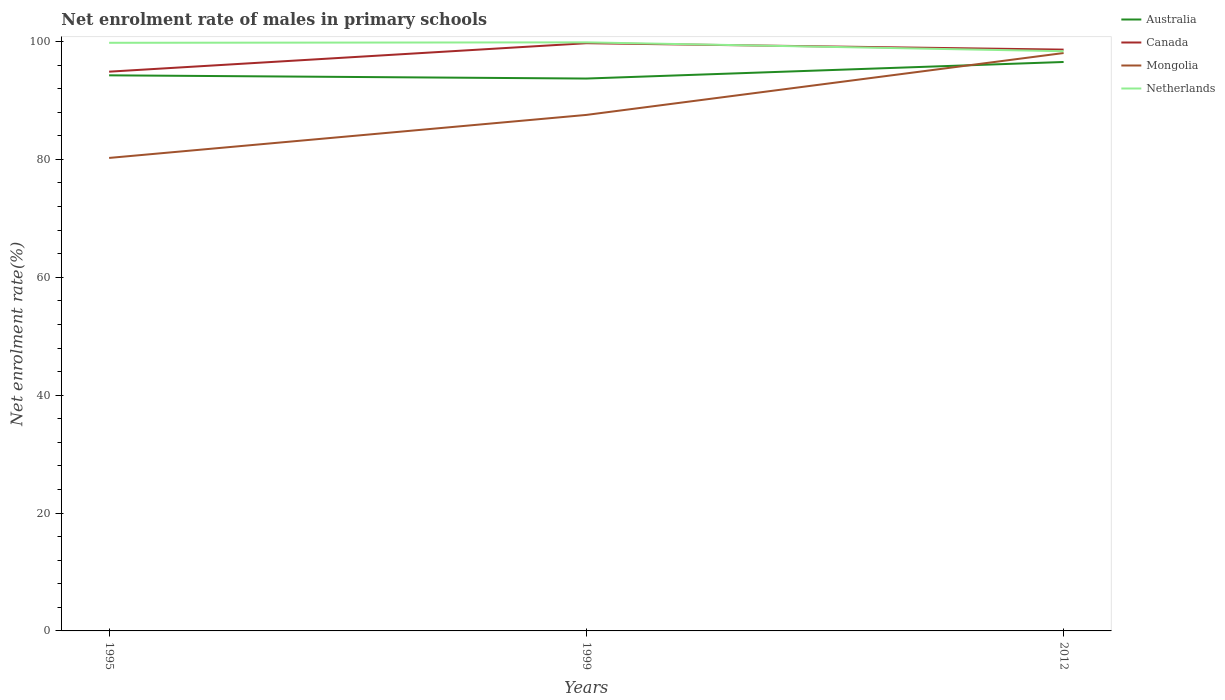Across all years, what is the maximum net enrolment rate of males in primary schools in Australia?
Offer a very short reply. 93.72. What is the total net enrolment rate of males in primary schools in Canada in the graph?
Offer a very short reply. -3.74. What is the difference between the highest and the second highest net enrolment rate of males in primary schools in Netherlands?
Your answer should be very brief. 1.51. How many years are there in the graph?
Offer a terse response. 3. Are the values on the major ticks of Y-axis written in scientific E-notation?
Your response must be concise. No. How many legend labels are there?
Give a very brief answer. 4. What is the title of the graph?
Your answer should be compact. Net enrolment rate of males in primary schools. Does "Faeroe Islands" appear as one of the legend labels in the graph?
Provide a short and direct response. No. What is the label or title of the Y-axis?
Provide a succinct answer. Net enrolment rate(%). What is the Net enrolment rate(%) in Australia in 1995?
Provide a succinct answer. 94.27. What is the Net enrolment rate(%) of Canada in 1995?
Provide a succinct answer. 94.89. What is the Net enrolment rate(%) in Mongolia in 1995?
Your response must be concise. 80.25. What is the Net enrolment rate(%) of Netherlands in 1995?
Your answer should be very brief. 99.79. What is the Net enrolment rate(%) of Australia in 1999?
Your answer should be compact. 93.72. What is the Net enrolment rate(%) of Canada in 1999?
Make the answer very short. 99.72. What is the Net enrolment rate(%) of Mongolia in 1999?
Offer a terse response. 87.55. What is the Net enrolment rate(%) in Netherlands in 1999?
Provide a succinct answer. 99.86. What is the Net enrolment rate(%) of Australia in 2012?
Provide a short and direct response. 96.53. What is the Net enrolment rate(%) of Canada in 2012?
Ensure brevity in your answer.  98.63. What is the Net enrolment rate(%) in Mongolia in 2012?
Give a very brief answer. 98.05. What is the Net enrolment rate(%) of Netherlands in 2012?
Offer a very short reply. 98.36. Across all years, what is the maximum Net enrolment rate(%) of Australia?
Keep it short and to the point. 96.53. Across all years, what is the maximum Net enrolment rate(%) in Canada?
Your response must be concise. 99.72. Across all years, what is the maximum Net enrolment rate(%) in Mongolia?
Your response must be concise. 98.05. Across all years, what is the maximum Net enrolment rate(%) in Netherlands?
Give a very brief answer. 99.86. Across all years, what is the minimum Net enrolment rate(%) of Australia?
Provide a short and direct response. 93.72. Across all years, what is the minimum Net enrolment rate(%) in Canada?
Provide a succinct answer. 94.89. Across all years, what is the minimum Net enrolment rate(%) of Mongolia?
Keep it short and to the point. 80.25. Across all years, what is the minimum Net enrolment rate(%) of Netherlands?
Provide a short and direct response. 98.36. What is the total Net enrolment rate(%) of Australia in the graph?
Make the answer very short. 284.52. What is the total Net enrolment rate(%) in Canada in the graph?
Provide a succinct answer. 293.23. What is the total Net enrolment rate(%) in Mongolia in the graph?
Offer a very short reply. 265.85. What is the total Net enrolment rate(%) of Netherlands in the graph?
Ensure brevity in your answer.  298. What is the difference between the Net enrolment rate(%) in Australia in 1995 and that in 1999?
Offer a terse response. 0.55. What is the difference between the Net enrolment rate(%) in Canada in 1995 and that in 1999?
Provide a succinct answer. -4.83. What is the difference between the Net enrolment rate(%) in Mongolia in 1995 and that in 1999?
Keep it short and to the point. -7.3. What is the difference between the Net enrolment rate(%) in Netherlands in 1995 and that in 1999?
Your response must be concise. -0.08. What is the difference between the Net enrolment rate(%) in Australia in 1995 and that in 2012?
Give a very brief answer. -2.26. What is the difference between the Net enrolment rate(%) in Canada in 1995 and that in 2012?
Keep it short and to the point. -3.74. What is the difference between the Net enrolment rate(%) in Mongolia in 1995 and that in 2012?
Ensure brevity in your answer.  -17.8. What is the difference between the Net enrolment rate(%) in Netherlands in 1995 and that in 2012?
Ensure brevity in your answer.  1.43. What is the difference between the Net enrolment rate(%) of Australia in 1999 and that in 2012?
Your answer should be compact. -2.81. What is the difference between the Net enrolment rate(%) of Canada in 1999 and that in 2012?
Keep it short and to the point. 1.09. What is the difference between the Net enrolment rate(%) of Mongolia in 1999 and that in 2012?
Offer a terse response. -10.5. What is the difference between the Net enrolment rate(%) in Netherlands in 1999 and that in 2012?
Offer a terse response. 1.51. What is the difference between the Net enrolment rate(%) in Australia in 1995 and the Net enrolment rate(%) in Canada in 1999?
Ensure brevity in your answer.  -5.45. What is the difference between the Net enrolment rate(%) in Australia in 1995 and the Net enrolment rate(%) in Mongolia in 1999?
Your answer should be very brief. 6.72. What is the difference between the Net enrolment rate(%) in Australia in 1995 and the Net enrolment rate(%) in Netherlands in 1999?
Ensure brevity in your answer.  -5.59. What is the difference between the Net enrolment rate(%) in Canada in 1995 and the Net enrolment rate(%) in Mongolia in 1999?
Your response must be concise. 7.34. What is the difference between the Net enrolment rate(%) in Canada in 1995 and the Net enrolment rate(%) in Netherlands in 1999?
Keep it short and to the point. -4.97. What is the difference between the Net enrolment rate(%) in Mongolia in 1995 and the Net enrolment rate(%) in Netherlands in 1999?
Offer a terse response. -19.61. What is the difference between the Net enrolment rate(%) of Australia in 1995 and the Net enrolment rate(%) of Canada in 2012?
Offer a terse response. -4.36. What is the difference between the Net enrolment rate(%) of Australia in 1995 and the Net enrolment rate(%) of Mongolia in 2012?
Offer a very short reply. -3.78. What is the difference between the Net enrolment rate(%) of Australia in 1995 and the Net enrolment rate(%) of Netherlands in 2012?
Your answer should be very brief. -4.09. What is the difference between the Net enrolment rate(%) of Canada in 1995 and the Net enrolment rate(%) of Mongolia in 2012?
Provide a short and direct response. -3.16. What is the difference between the Net enrolment rate(%) of Canada in 1995 and the Net enrolment rate(%) of Netherlands in 2012?
Offer a terse response. -3.47. What is the difference between the Net enrolment rate(%) of Mongolia in 1995 and the Net enrolment rate(%) of Netherlands in 2012?
Offer a very short reply. -18.1. What is the difference between the Net enrolment rate(%) in Australia in 1999 and the Net enrolment rate(%) in Canada in 2012?
Provide a short and direct response. -4.91. What is the difference between the Net enrolment rate(%) of Australia in 1999 and the Net enrolment rate(%) of Mongolia in 2012?
Offer a terse response. -4.33. What is the difference between the Net enrolment rate(%) of Australia in 1999 and the Net enrolment rate(%) of Netherlands in 2012?
Give a very brief answer. -4.64. What is the difference between the Net enrolment rate(%) of Canada in 1999 and the Net enrolment rate(%) of Mongolia in 2012?
Your answer should be very brief. 1.67. What is the difference between the Net enrolment rate(%) of Canada in 1999 and the Net enrolment rate(%) of Netherlands in 2012?
Your response must be concise. 1.36. What is the difference between the Net enrolment rate(%) of Mongolia in 1999 and the Net enrolment rate(%) of Netherlands in 2012?
Your response must be concise. -10.81. What is the average Net enrolment rate(%) of Australia per year?
Keep it short and to the point. 94.84. What is the average Net enrolment rate(%) of Canada per year?
Your answer should be very brief. 97.74. What is the average Net enrolment rate(%) in Mongolia per year?
Your answer should be very brief. 88.62. What is the average Net enrolment rate(%) in Netherlands per year?
Your response must be concise. 99.33. In the year 1995, what is the difference between the Net enrolment rate(%) in Australia and Net enrolment rate(%) in Canada?
Offer a terse response. -0.62. In the year 1995, what is the difference between the Net enrolment rate(%) of Australia and Net enrolment rate(%) of Mongolia?
Provide a succinct answer. 14.02. In the year 1995, what is the difference between the Net enrolment rate(%) of Australia and Net enrolment rate(%) of Netherlands?
Give a very brief answer. -5.52. In the year 1995, what is the difference between the Net enrolment rate(%) in Canada and Net enrolment rate(%) in Mongolia?
Provide a short and direct response. 14.63. In the year 1995, what is the difference between the Net enrolment rate(%) of Canada and Net enrolment rate(%) of Netherlands?
Keep it short and to the point. -4.9. In the year 1995, what is the difference between the Net enrolment rate(%) in Mongolia and Net enrolment rate(%) in Netherlands?
Make the answer very short. -19.53. In the year 1999, what is the difference between the Net enrolment rate(%) of Australia and Net enrolment rate(%) of Canada?
Offer a very short reply. -6. In the year 1999, what is the difference between the Net enrolment rate(%) in Australia and Net enrolment rate(%) in Mongolia?
Your answer should be very brief. 6.17. In the year 1999, what is the difference between the Net enrolment rate(%) in Australia and Net enrolment rate(%) in Netherlands?
Offer a terse response. -6.14. In the year 1999, what is the difference between the Net enrolment rate(%) in Canada and Net enrolment rate(%) in Mongolia?
Provide a short and direct response. 12.17. In the year 1999, what is the difference between the Net enrolment rate(%) of Canada and Net enrolment rate(%) of Netherlands?
Your answer should be compact. -0.14. In the year 1999, what is the difference between the Net enrolment rate(%) in Mongolia and Net enrolment rate(%) in Netherlands?
Offer a very short reply. -12.31. In the year 2012, what is the difference between the Net enrolment rate(%) of Australia and Net enrolment rate(%) of Canada?
Keep it short and to the point. -2.1. In the year 2012, what is the difference between the Net enrolment rate(%) of Australia and Net enrolment rate(%) of Mongolia?
Give a very brief answer. -1.52. In the year 2012, what is the difference between the Net enrolment rate(%) of Australia and Net enrolment rate(%) of Netherlands?
Provide a succinct answer. -1.82. In the year 2012, what is the difference between the Net enrolment rate(%) in Canada and Net enrolment rate(%) in Mongolia?
Your answer should be very brief. 0.58. In the year 2012, what is the difference between the Net enrolment rate(%) in Canada and Net enrolment rate(%) in Netherlands?
Make the answer very short. 0.27. In the year 2012, what is the difference between the Net enrolment rate(%) of Mongolia and Net enrolment rate(%) of Netherlands?
Your answer should be compact. -0.3. What is the ratio of the Net enrolment rate(%) in Australia in 1995 to that in 1999?
Make the answer very short. 1.01. What is the ratio of the Net enrolment rate(%) of Canada in 1995 to that in 1999?
Your answer should be very brief. 0.95. What is the ratio of the Net enrolment rate(%) in Mongolia in 1995 to that in 1999?
Make the answer very short. 0.92. What is the ratio of the Net enrolment rate(%) in Netherlands in 1995 to that in 1999?
Offer a terse response. 1. What is the ratio of the Net enrolment rate(%) in Australia in 1995 to that in 2012?
Give a very brief answer. 0.98. What is the ratio of the Net enrolment rate(%) in Canada in 1995 to that in 2012?
Offer a very short reply. 0.96. What is the ratio of the Net enrolment rate(%) of Mongolia in 1995 to that in 2012?
Keep it short and to the point. 0.82. What is the ratio of the Net enrolment rate(%) in Netherlands in 1995 to that in 2012?
Ensure brevity in your answer.  1.01. What is the ratio of the Net enrolment rate(%) in Australia in 1999 to that in 2012?
Provide a succinct answer. 0.97. What is the ratio of the Net enrolment rate(%) of Mongolia in 1999 to that in 2012?
Offer a terse response. 0.89. What is the ratio of the Net enrolment rate(%) of Netherlands in 1999 to that in 2012?
Ensure brevity in your answer.  1.02. What is the difference between the highest and the second highest Net enrolment rate(%) of Australia?
Offer a very short reply. 2.26. What is the difference between the highest and the second highest Net enrolment rate(%) of Canada?
Offer a very short reply. 1.09. What is the difference between the highest and the second highest Net enrolment rate(%) in Mongolia?
Give a very brief answer. 10.5. What is the difference between the highest and the second highest Net enrolment rate(%) of Netherlands?
Your answer should be compact. 0.08. What is the difference between the highest and the lowest Net enrolment rate(%) of Australia?
Offer a terse response. 2.81. What is the difference between the highest and the lowest Net enrolment rate(%) in Canada?
Your response must be concise. 4.83. What is the difference between the highest and the lowest Net enrolment rate(%) of Mongolia?
Offer a very short reply. 17.8. What is the difference between the highest and the lowest Net enrolment rate(%) of Netherlands?
Offer a very short reply. 1.51. 